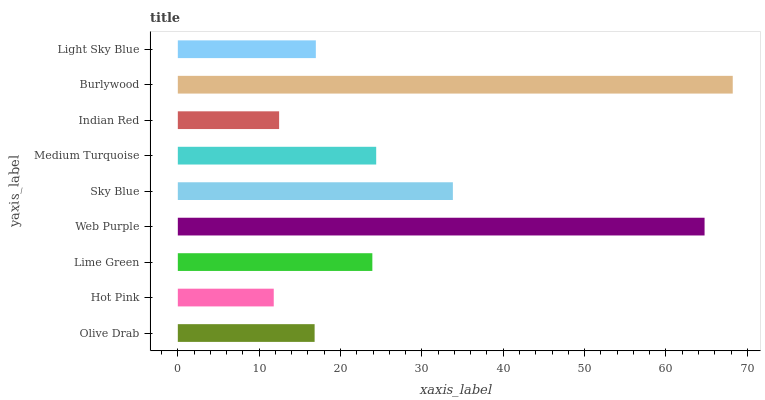Is Hot Pink the minimum?
Answer yes or no. Yes. Is Burlywood the maximum?
Answer yes or no. Yes. Is Lime Green the minimum?
Answer yes or no. No. Is Lime Green the maximum?
Answer yes or no. No. Is Lime Green greater than Hot Pink?
Answer yes or no. Yes. Is Hot Pink less than Lime Green?
Answer yes or no. Yes. Is Hot Pink greater than Lime Green?
Answer yes or no. No. Is Lime Green less than Hot Pink?
Answer yes or no. No. Is Lime Green the high median?
Answer yes or no. Yes. Is Lime Green the low median?
Answer yes or no. Yes. Is Light Sky Blue the high median?
Answer yes or no. No. Is Olive Drab the low median?
Answer yes or no. No. 